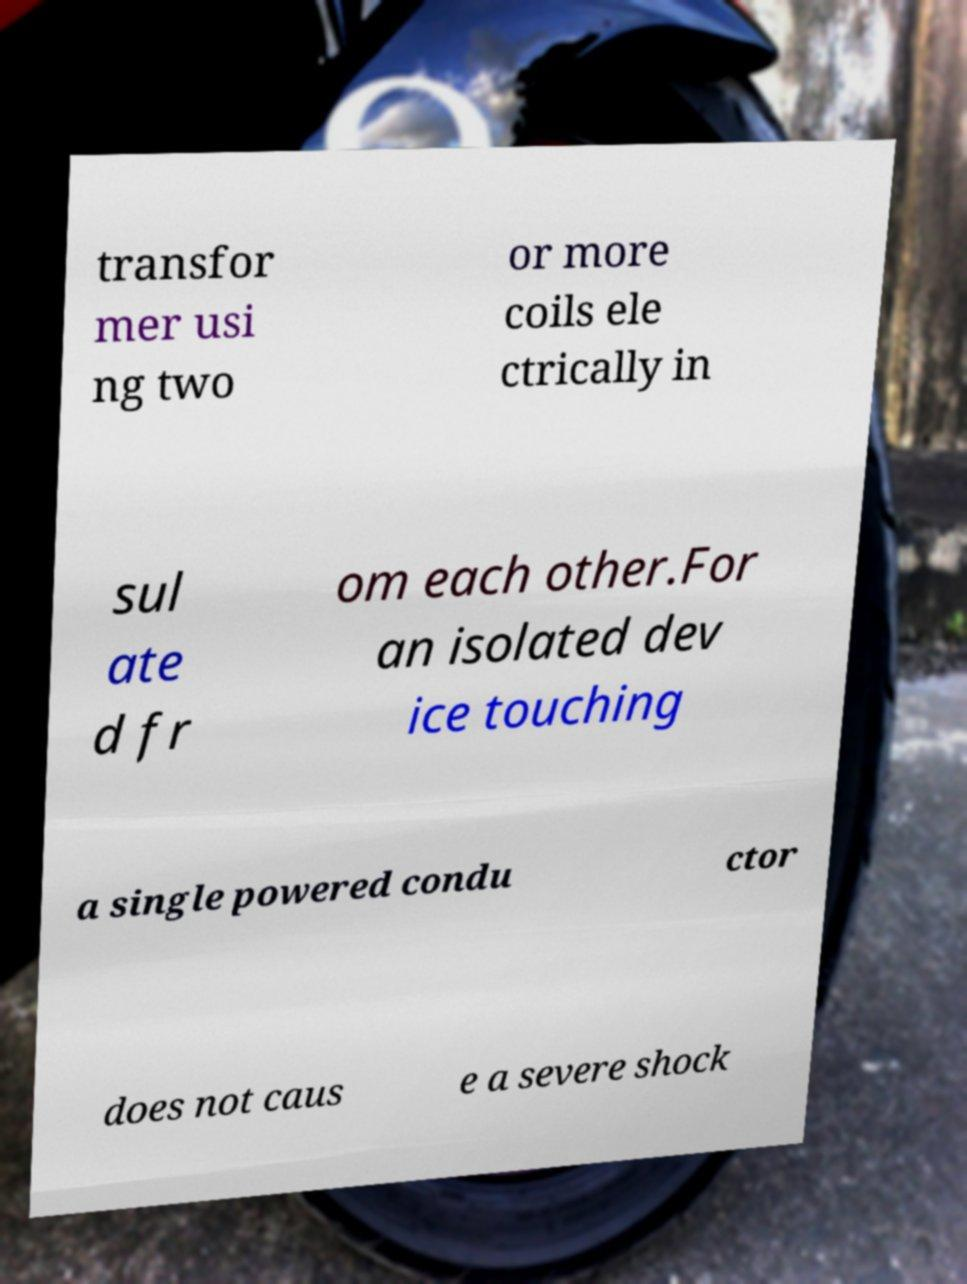What messages or text are displayed in this image? I need them in a readable, typed format. transfor mer usi ng two or more coils ele ctrically in sul ate d fr om each other.For an isolated dev ice touching a single powered condu ctor does not caus e a severe shock 